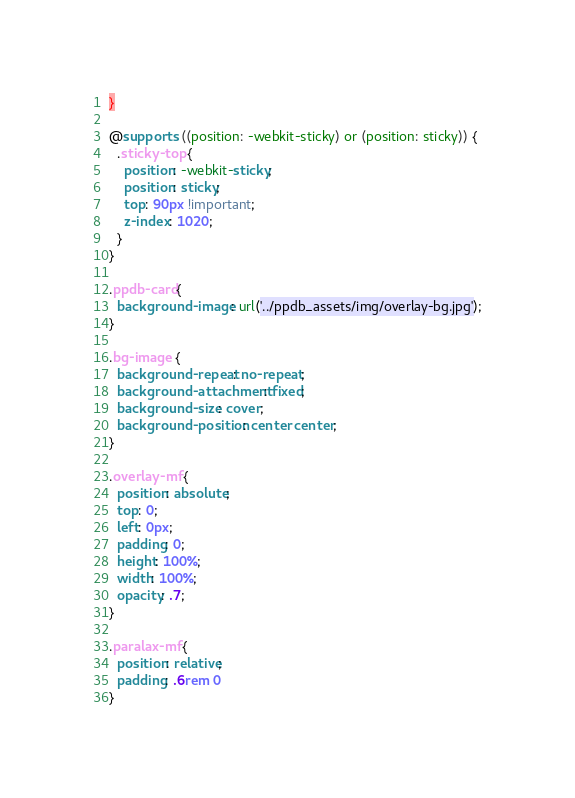Convert code to text. <code><loc_0><loc_0><loc_500><loc_500><_CSS_>}

@supports ((position: -webkit-sticky) or (position: sticky)) {
  .sticky-top {
    position: -webkit-sticky;
    position: sticky;
    top: 90px !important;
    z-index: 1020;
  }
}

.ppdb-card{
  background-image: url('../ppdb_assets/img/overlay-bg.jpg');
}

.bg-image {
  background-repeat: no-repeat;
  background-attachment: fixed;
  background-size: cover;
  background-position: center center;
}

.overlay-mf {
  position: absolute;
  top: 0;
  left: 0px;
  padding: 0;
  height: 100%;
  width: 100%;
  opacity: .7;
}

.paralax-mf {
  position: relative;
  padding: .6rem 0
}</code> 